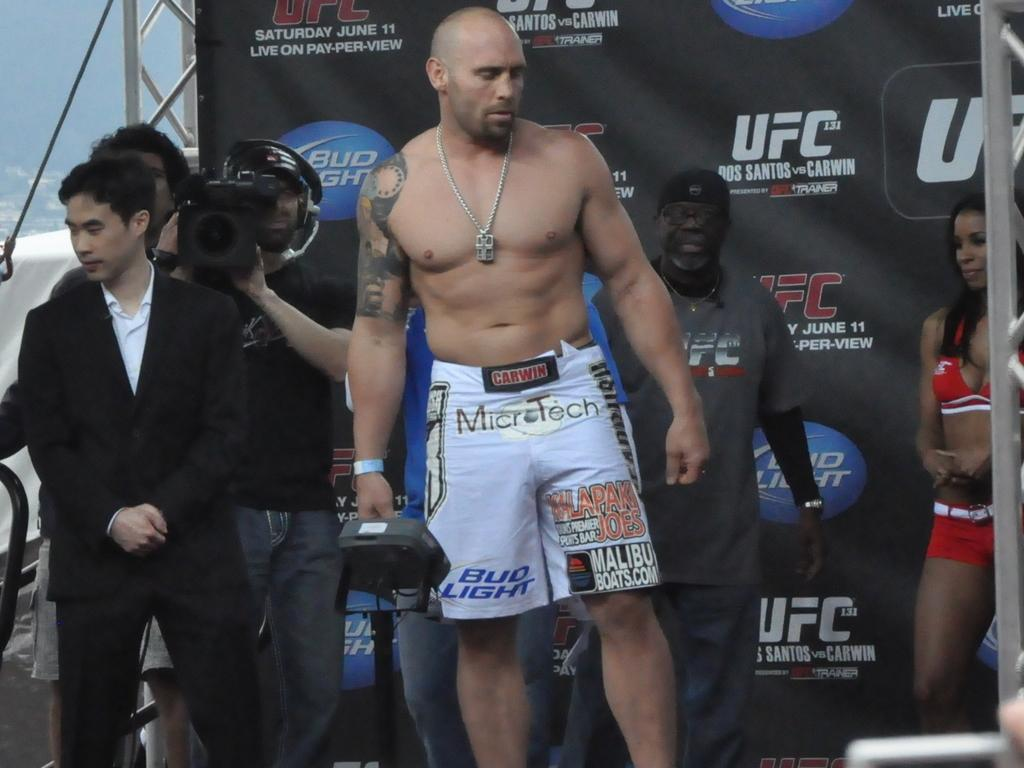<image>
Write a terse but informative summary of the picture. a man with muscles in front of a UFC sign 